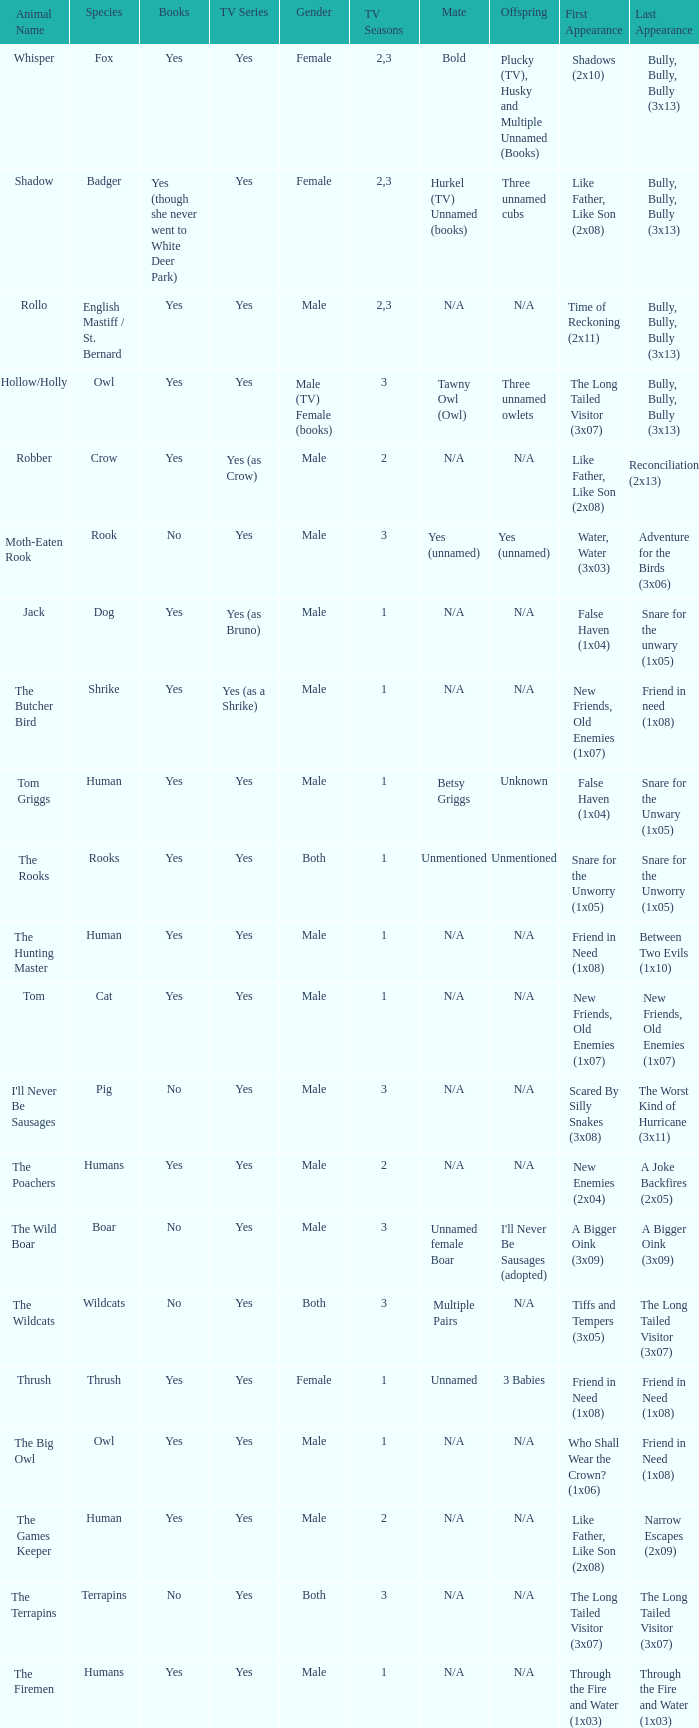What animal was yes for tv series and was a terrapins? The Terrapins. 